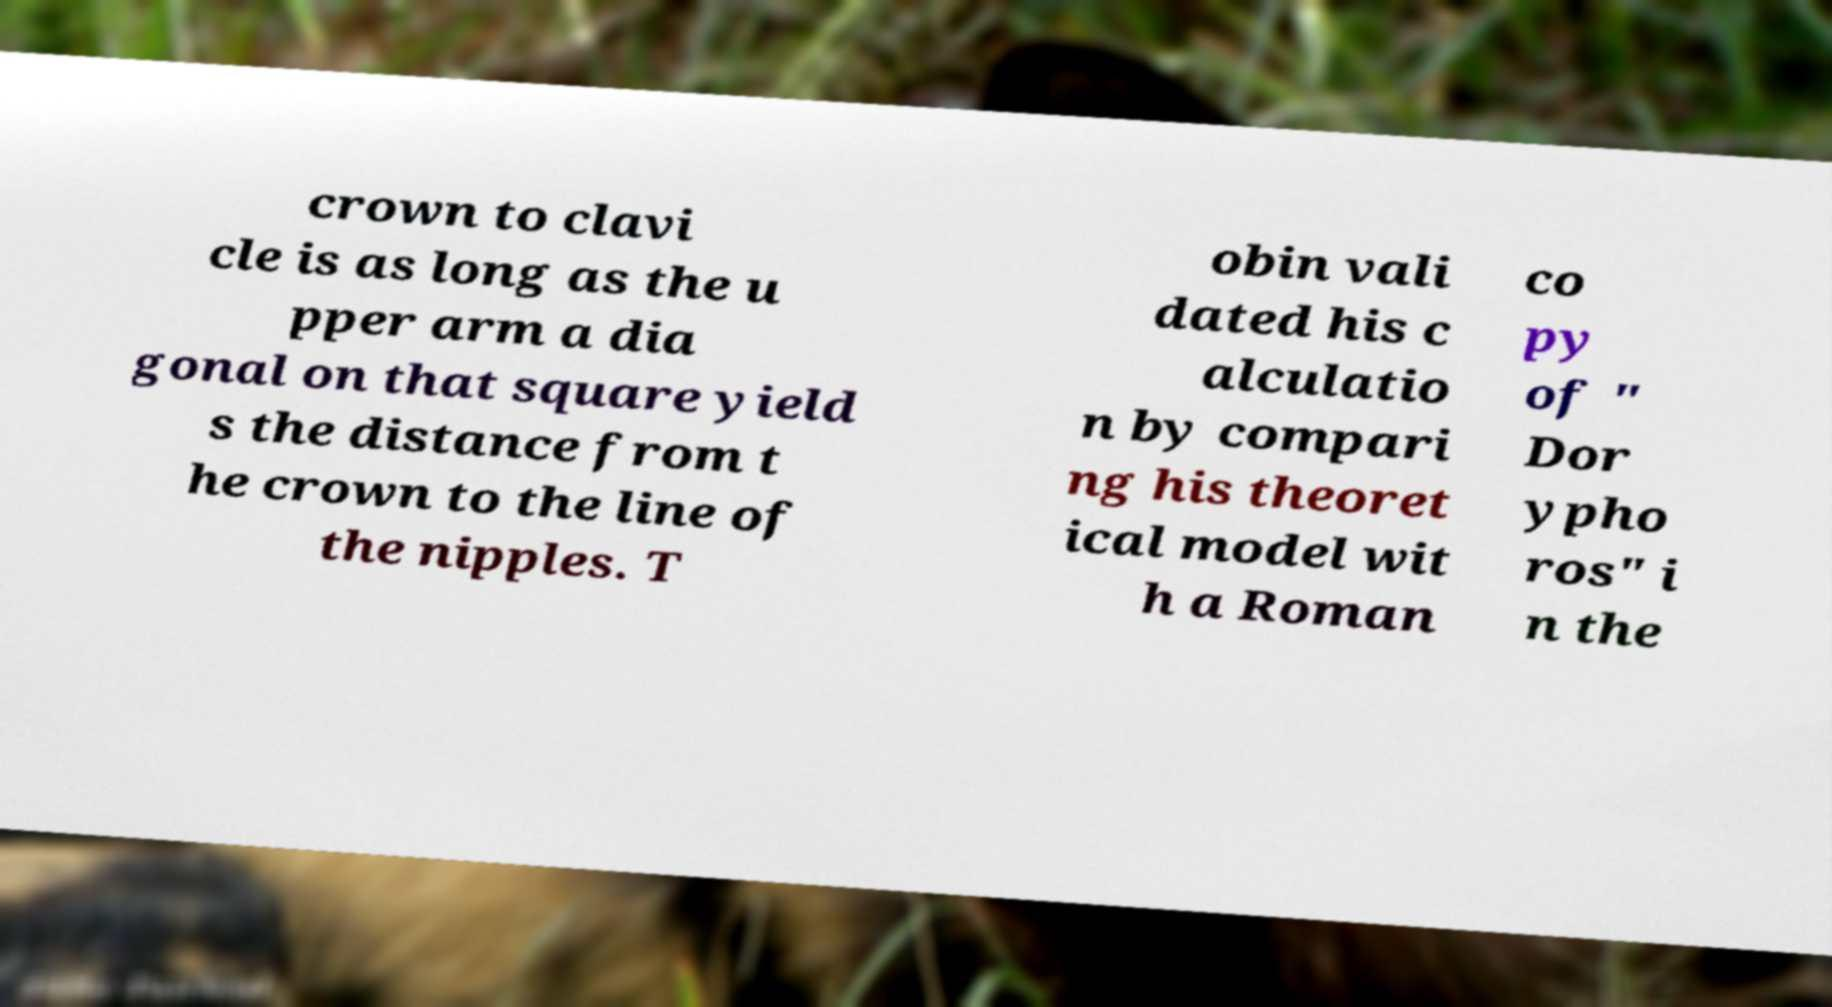Could you assist in decoding the text presented in this image and type it out clearly? crown to clavi cle is as long as the u pper arm a dia gonal on that square yield s the distance from t he crown to the line of the nipples. T obin vali dated his c alculatio n by compari ng his theoret ical model wit h a Roman co py of " Dor ypho ros" i n the 